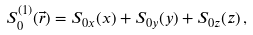<formula> <loc_0><loc_0><loc_500><loc_500>S _ { 0 } ^ { ( 1 ) } ( \vec { r } ) = S _ { 0 x } ( x ) + S _ { 0 y } ( y ) + S _ { 0 z } ( z ) \, ,</formula> 